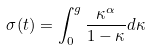<formula> <loc_0><loc_0><loc_500><loc_500>\sigma ( t ) = \int _ { 0 } ^ { g } \frac { \kappa ^ { \alpha } } { 1 - \kappa } d \kappa</formula> 